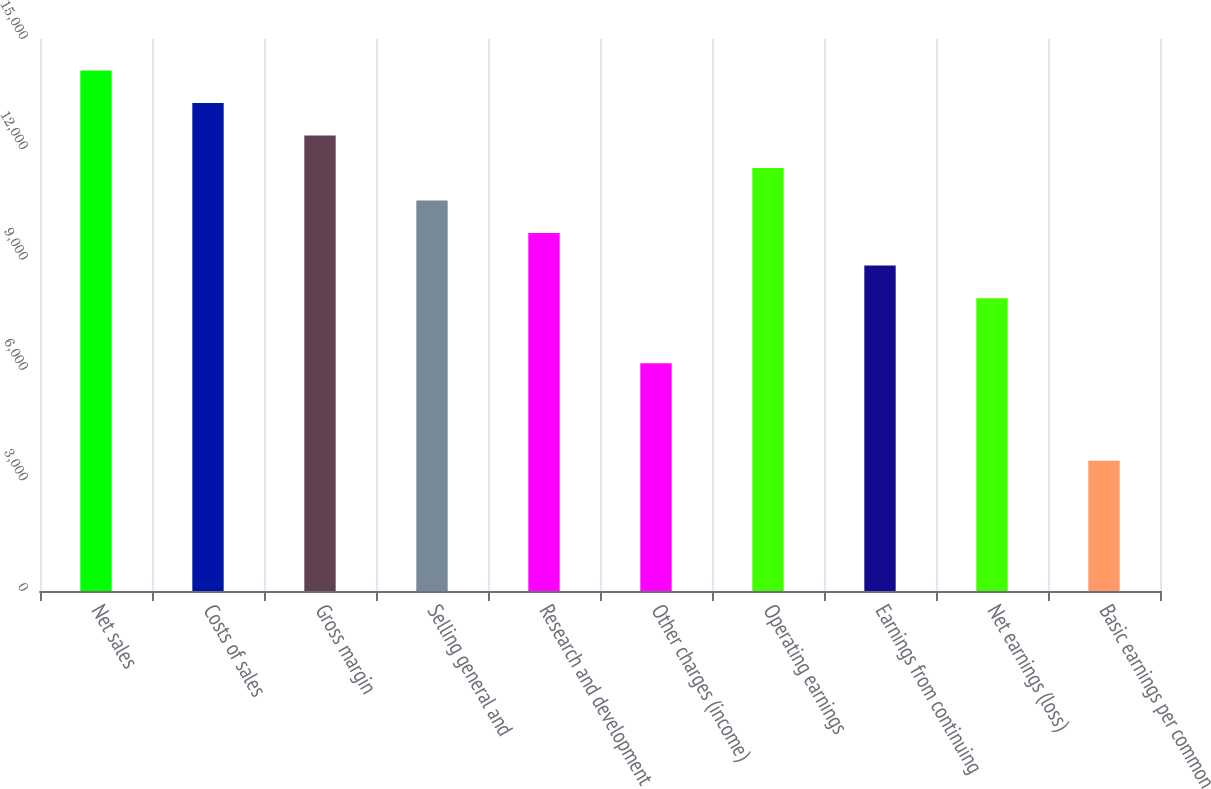<chart> <loc_0><loc_0><loc_500><loc_500><bar_chart><fcel>Net sales<fcel>Costs of sales<fcel>Gross margin<fcel>Selling general and<fcel>Research and development<fcel>Other charges (income)<fcel>Operating earnings<fcel>Earnings from continuing<fcel>Net earnings (loss)<fcel>Basic earnings per common<nl><fcel>14147.2<fcel>13263<fcel>12378.8<fcel>10610.4<fcel>9726.24<fcel>6189.44<fcel>11494.6<fcel>8842.04<fcel>7957.84<fcel>3536.84<nl></chart> 